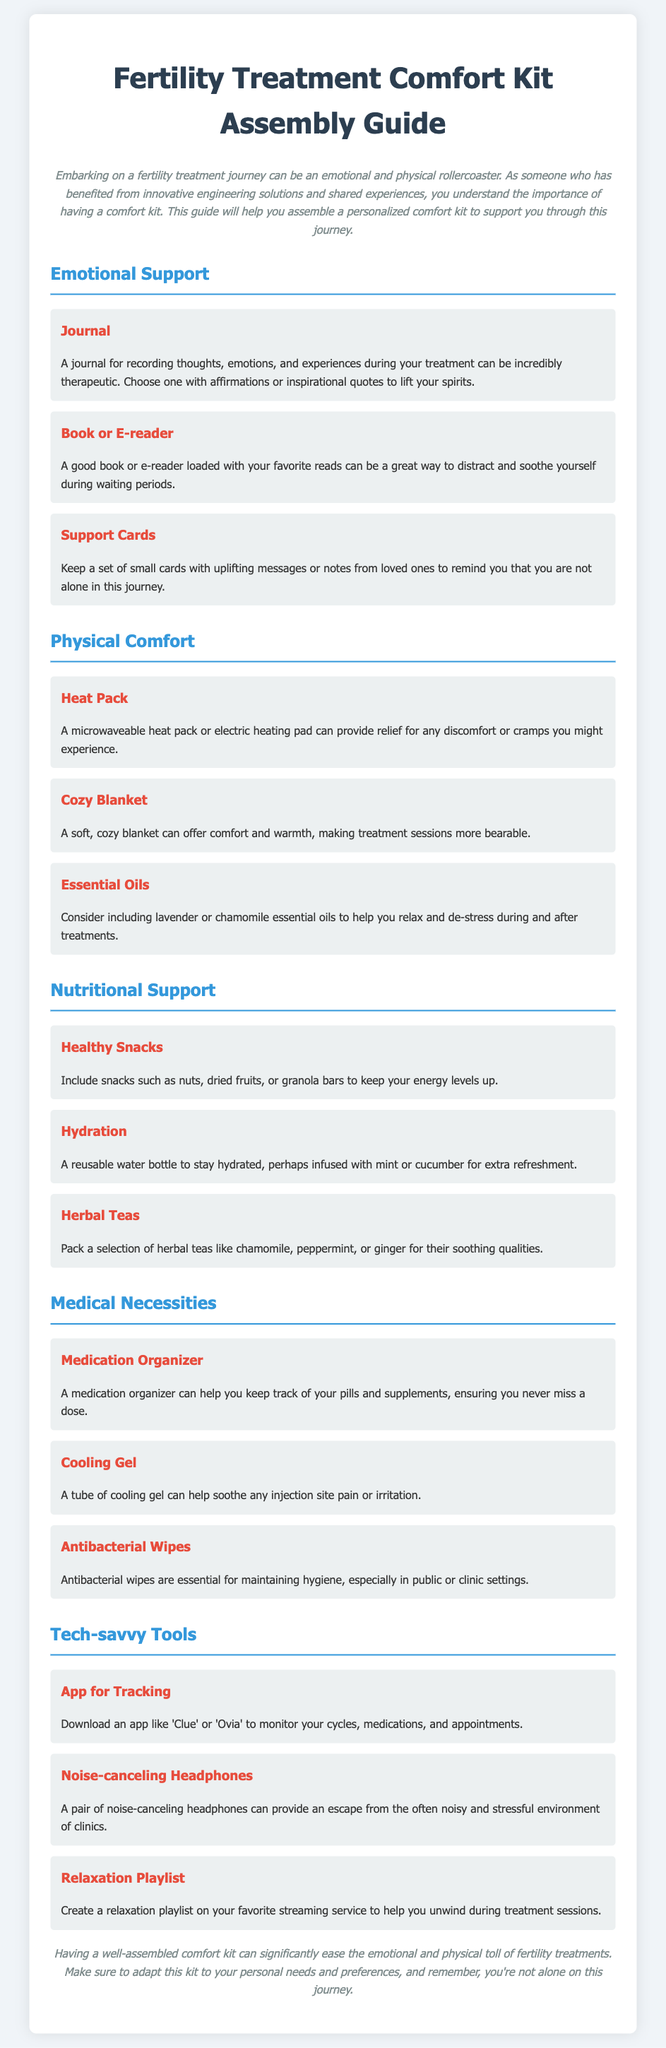What is the title of the document? The title of the document is displayed at the top of the page, indicating its purpose.
Answer: Fertility Treatment Comfort Kit Assembly Guide How many categories are in the comfort kit? The document outlines four distinct categories for the comfort kit items.
Answer: Four What item is recommended for emotional support? One of the items listed under emotional support is specifically aimed at helping patients process their experiences.
Answer: Journal Which essential oil is mentioned in the document? The document suggests including essential oils known for their calming properties.
Answer: Lavender What is the purpose of a medication organizer? The medication organizer is intended to help manage medication intake throughout the treatment.
Answer: To keep track of pills and supplements What should you include for hydration? The document specifies a necessary item to ensure adequate hydration during treatment.
Answer: Reusable water bottle Name one of the tech-savvy tools mentioned. The document lists several tools; one is used for monitoring cycles and medications.
Answer: App for Tracking What does the comfort kit aim to ease? The overall goal of the comfort kit is to alleviate a specific type of toll during treatment.
Answer: Emotional and physical toll 